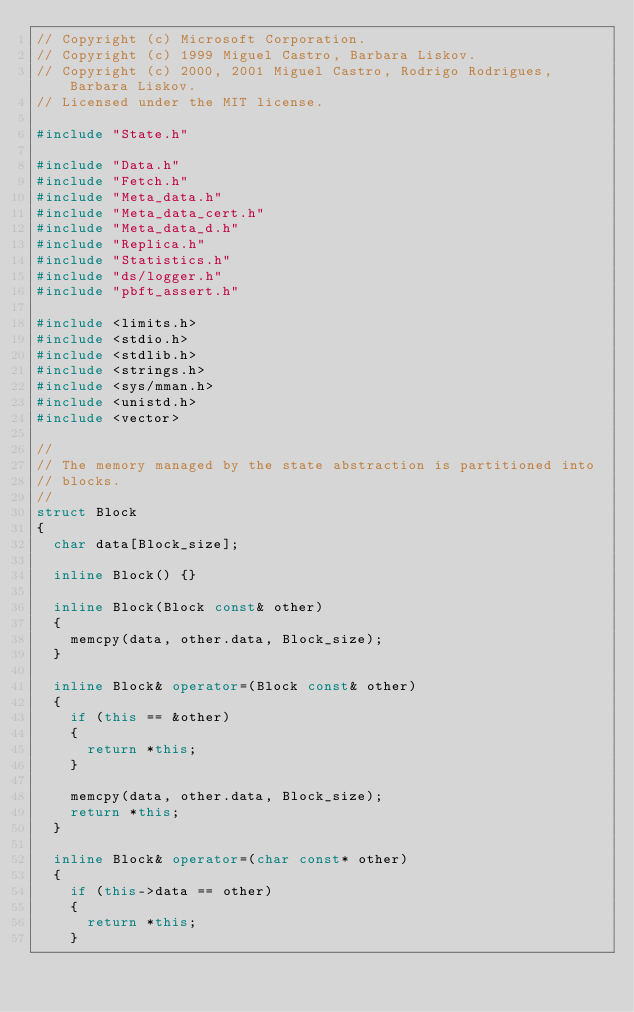Convert code to text. <code><loc_0><loc_0><loc_500><loc_500><_C++_>// Copyright (c) Microsoft Corporation.
// Copyright (c) 1999 Miguel Castro, Barbara Liskov.
// Copyright (c) 2000, 2001 Miguel Castro, Rodrigo Rodrigues, Barbara Liskov.
// Licensed under the MIT license.

#include "State.h"

#include "Data.h"
#include "Fetch.h"
#include "Meta_data.h"
#include "Meta_data_cert.h"
#include "Meta_data_d.h"
#include "Replica.h"
#include "Statistics.h"
#include "ds/logger.h"
#include "pbft_assert.h"

#include <limits.h>
#include <stdio.h>
#include <stdlib.h>
#include <strings.h>
#include <sys/mman.h>
#include <unistd.h>
#include <vector>

//
// The memory managed by the state abstraction is partitioned into
// blocks.
//
struct Block
{
  char data[Block_size];

  inline Block() {}

  inline Block(Block const& other)
  {
    memcpy(data, other.data, Block_size);
  }

  inline Block& operator=(Block const& other)
  {
    if (this == &other)
    {
      return *this;
    }

    memcpy(data, other.data, Block_size);
    return *this;
  }

  inline Block& operator=(char const* other)
  {
    if (this->data == other)
    {
      return *this;
    }
</code> 